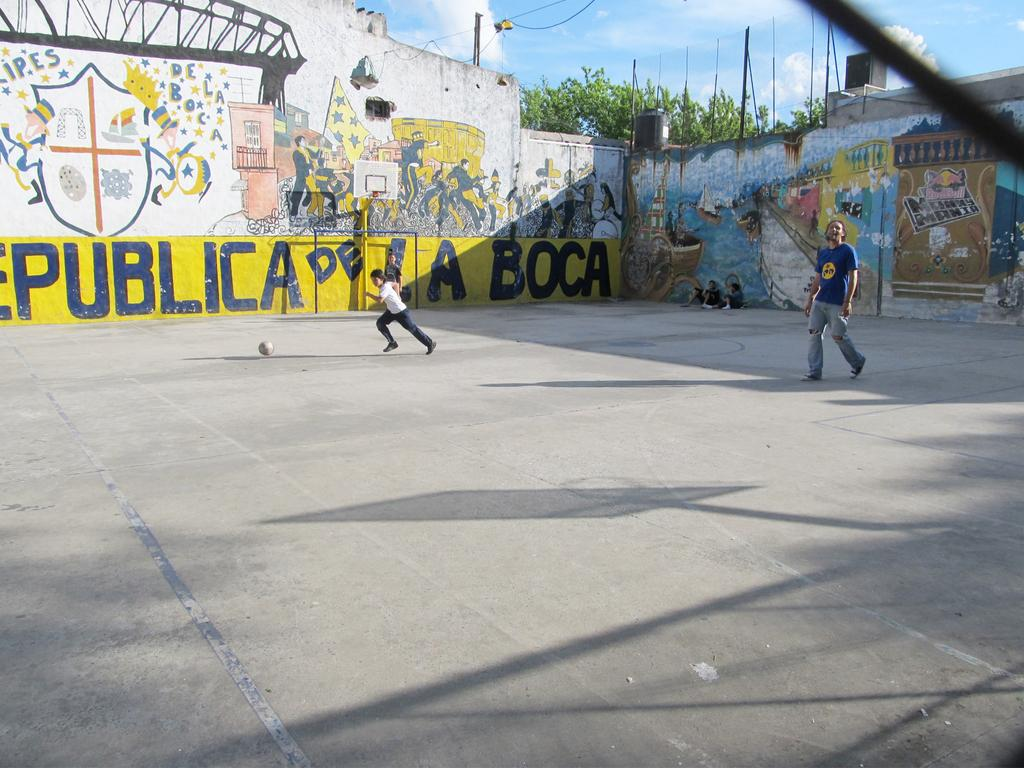What is the person in the image doing? There is a person running in the image. What can be seen in the middle of the image? There is a ball in the middle of the image. Can you describe the person on the right side of the image? There is a man running on the right side of the image, and he is wearing a t-shirt. What is present on the wall in the image? There are paintings on the wall in the image. What type of sign can be seen on the wall in the image? There is no sign present on the wall in the image; it only has paintings. What material is the ball made of in the image? The material of the ball cannot be determined from the image. 